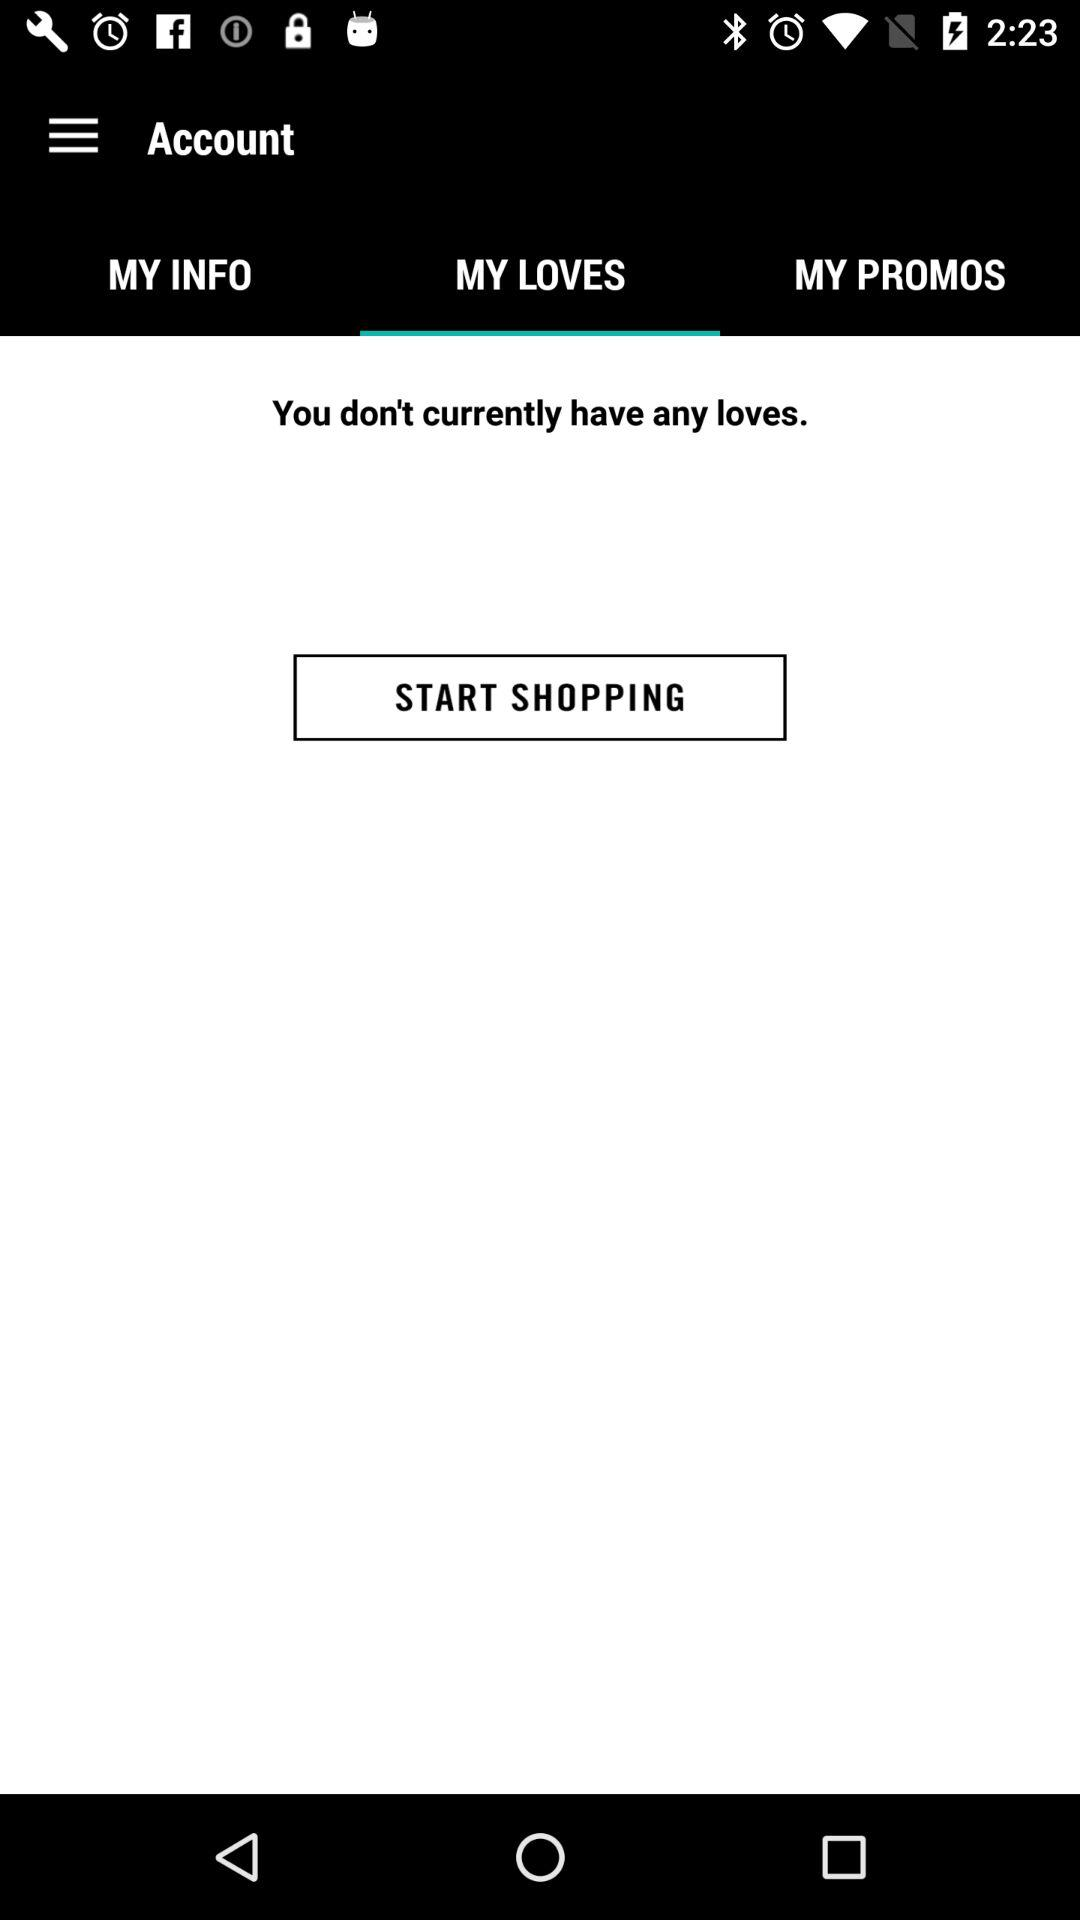Which tab is selected? The selected tab is "MY LOVES". 